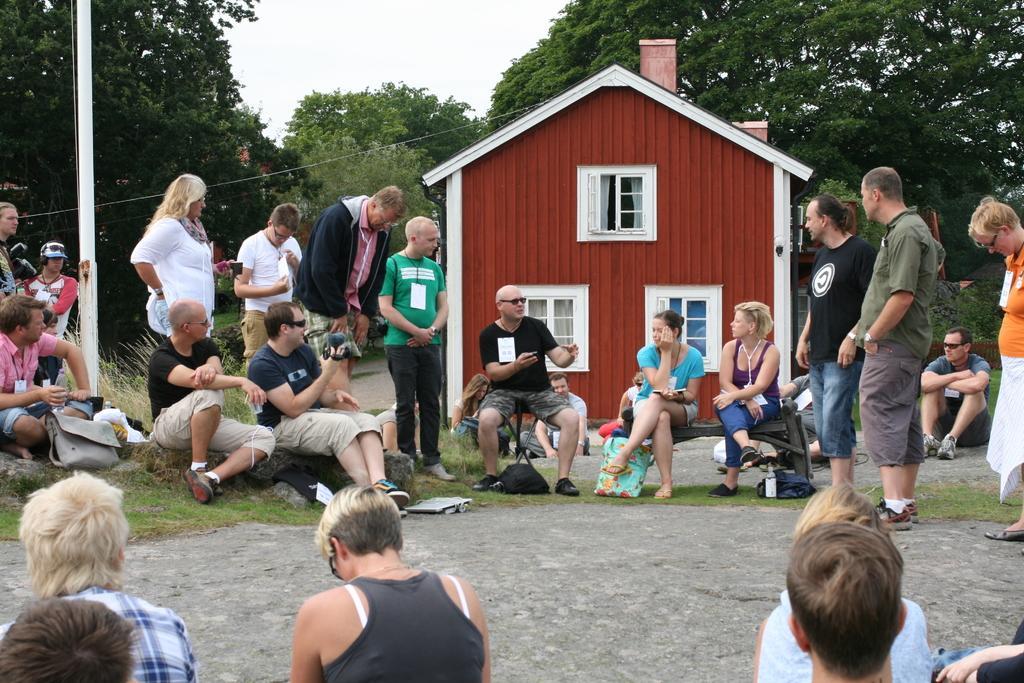How would you summarize this image in a sentence or two? In this picture I can see there are a group of people, few are standing and few of them are sitting. In the backdrop there are trees and there is a pole at left, the sky is clear. 